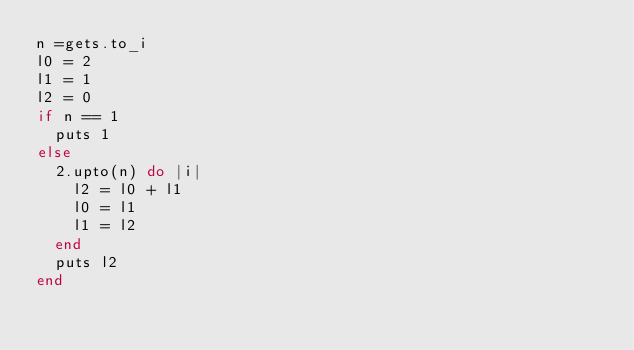Convert code to text. <code><loc_0><loc_0><loc_500><loc_500><_Ruby_>n =gets.to_i
l0 = 2
l1 = 1
l2 = 0
if n == 1
  puts 1
else
  2.upto(n) do |i|
    l2 = l0 + l1
    l0 = l1
    l1 = l2
  end
  puts l2
end

  </code> 